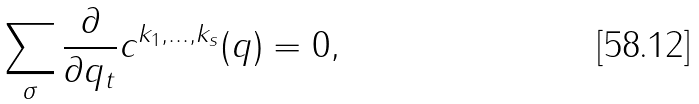<formula> <loc_0><loc_0><loc_500><loc_500>\sum _ { \sigma } \frac { \partial } { \partial q _ { t } } c ^ { k _ { 1 } , \dots , k _ { s } } ( q ) = 0 ,</formula> 